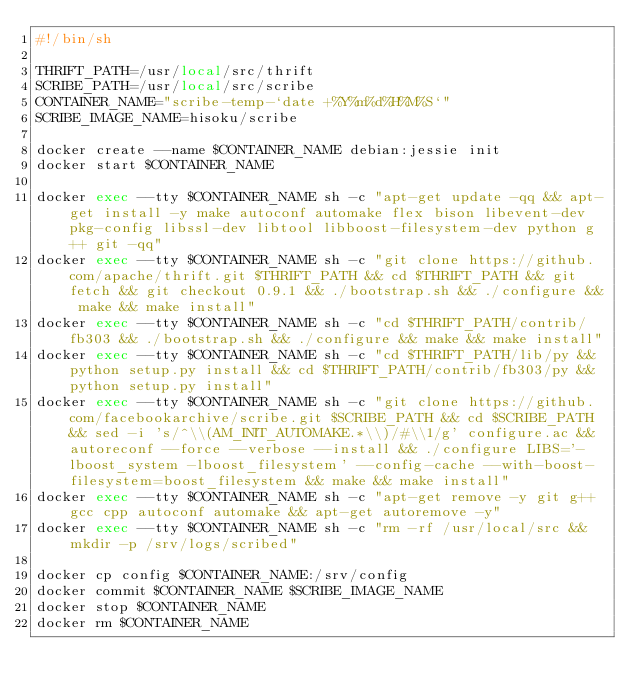Convert code to text. <code><loc_0><loc_0><loc_500><loc_500><_Bash_>#!/bin/sh

THRIFT_PATH=/usr/local/src/thrift
SCRIBE_PATH=/usr/local/src/scribe
CONTAINER_NAME="scribe-temp-`date +%Y%m%d%H%M%S`"
SCRIBE_IMAGE_NAME=hisoku/scribe

docker create --name $CONTAINER_NAME debian:jessie init
docker start $CONTAINER_NAME

docker exec --tty $CONTAINER_NAME sh -c "apt-get update -qq && apt-get install -y make autoconf automake flex bison libevent-dev pkg-config libssl-dev libtool libboost-filesystem-dev python g++ git -qq"
docker exec --tty $CONTAINER_NAME sh -c "git clone https://github.com/apache/thrift.git $THRIFT_PATH && cd $THRIFT_PATH && git fetch && git checkout 0.9.1 && ./bootstrap.sh && ./configure && make && make install"
docker exec --tty $CONTAINER_NAME sh -c "cd $THRIFT_PATH/contrib/fb303 && ./bootstrap.sh && ./configure && make && make install"
docker exec --tty $CONTAINER_NAME sh -c "cd $THRIFT_PATH/lib/py && python setup.py install && cd $THRIFT_PATH/contrib/fb303/py && python setup.py install"
docker exec --tty $CONTAINER_NAME sh -c "git clone https://github.com/facebookarchive/scribe.git $SCRIBE_PATH && cd $SCRIBE_PATH && sed -i 's/^\\(AM_INIT_AUTOMAKE.*\\)/#\\1/g' configure.ac && autoreconf --force --verbose --install && ./configure LIBS='-lboost_system -lboost_filesystem' --config-cache --with-boost-filesystem=boost_filesystem && make && make install"
docker exec --tty $CONTAINER_NAME sh -c "apt-get remove -y git g++ gcc cpp autoconf automake && apt-get autoremove -y"
docker exec --tty $CONTAINER_NAME sh -c "rm -rf /usr/local/src && mkdir -p /srv/logs/scribed"

docker cp config $CONTAINER_NAME:/srv/config
docker commit $CONTAINER_NAME $SCRIBE_IMAGE_NAME
docker stop $CONTAINER_NAME
docker rm $CONTAINER_NAME
</code> 